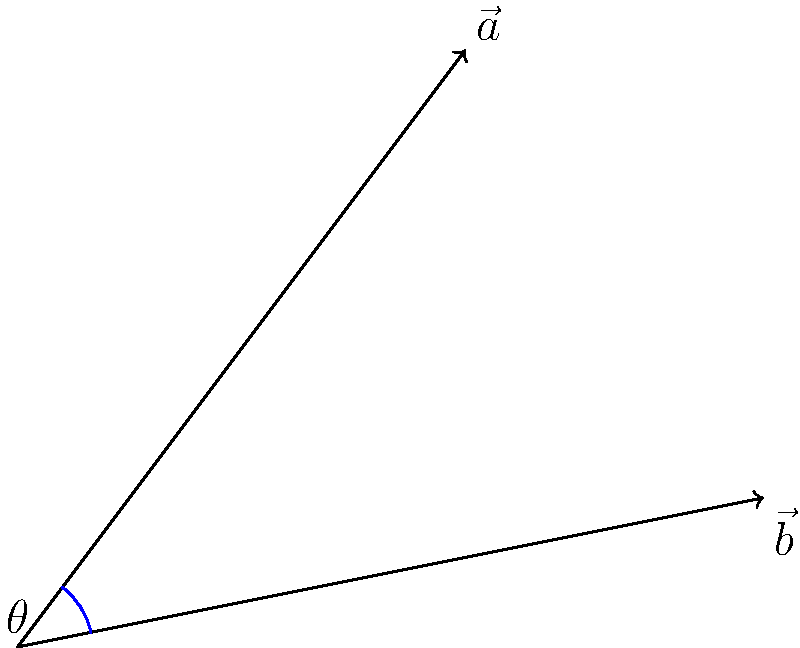In the classic Rare game "GoldenEye 007", you're trying to determine if an enemy guard can spot James Bond. Given two vectors representing the guard's line of sight $\vec{a} = (3, 4)$ and Bond's position $\vec{b} = (5, 1)$ relative to the guard, calculate the angle $\theta$ between these vectors. Round your answer to the nearest degree. To find the angle between two vectors, we can use the dot product formula:

$$\cos \theta = \frac{\vec{a} \cdot \vec{b}}{|\vec{a}||\vec{b}|}$$

Step 1: Calculate the dot product $\vec{a} \cdot \vec{b}$
$$\vec{a} \cdot \vec{b} = (3 \times 5) + (4 \times 1) = 15 + 4 = 19$$

Step 2: Calculate the magnitudes of $\vec{a}$ and $\vec{b}$
$$|\vec{a}| = \sqrt{3^2 + 4^2} = \sqrt{9 + 16} = \sqrt{25} = 5$$
$$|\vec{b}| = \sqrt{5^2 + 1^2} = \sqrt{25 + 1} = \sqrt{26}$$

Step 3: Substitute into the formula
$$\cos \theta = \frac{19}{5\sqrt{26}}$$

Step 4: Take the inverse cosine (arccos) of both sides
$$\theta = \arccos(\frac{19}{5\sqrt{26}})$$

Step 5: Calculate and round to the nearest degree
$$\theta \approx 40.28^\circ \approx 40^\circ$$
Answer: 40° 